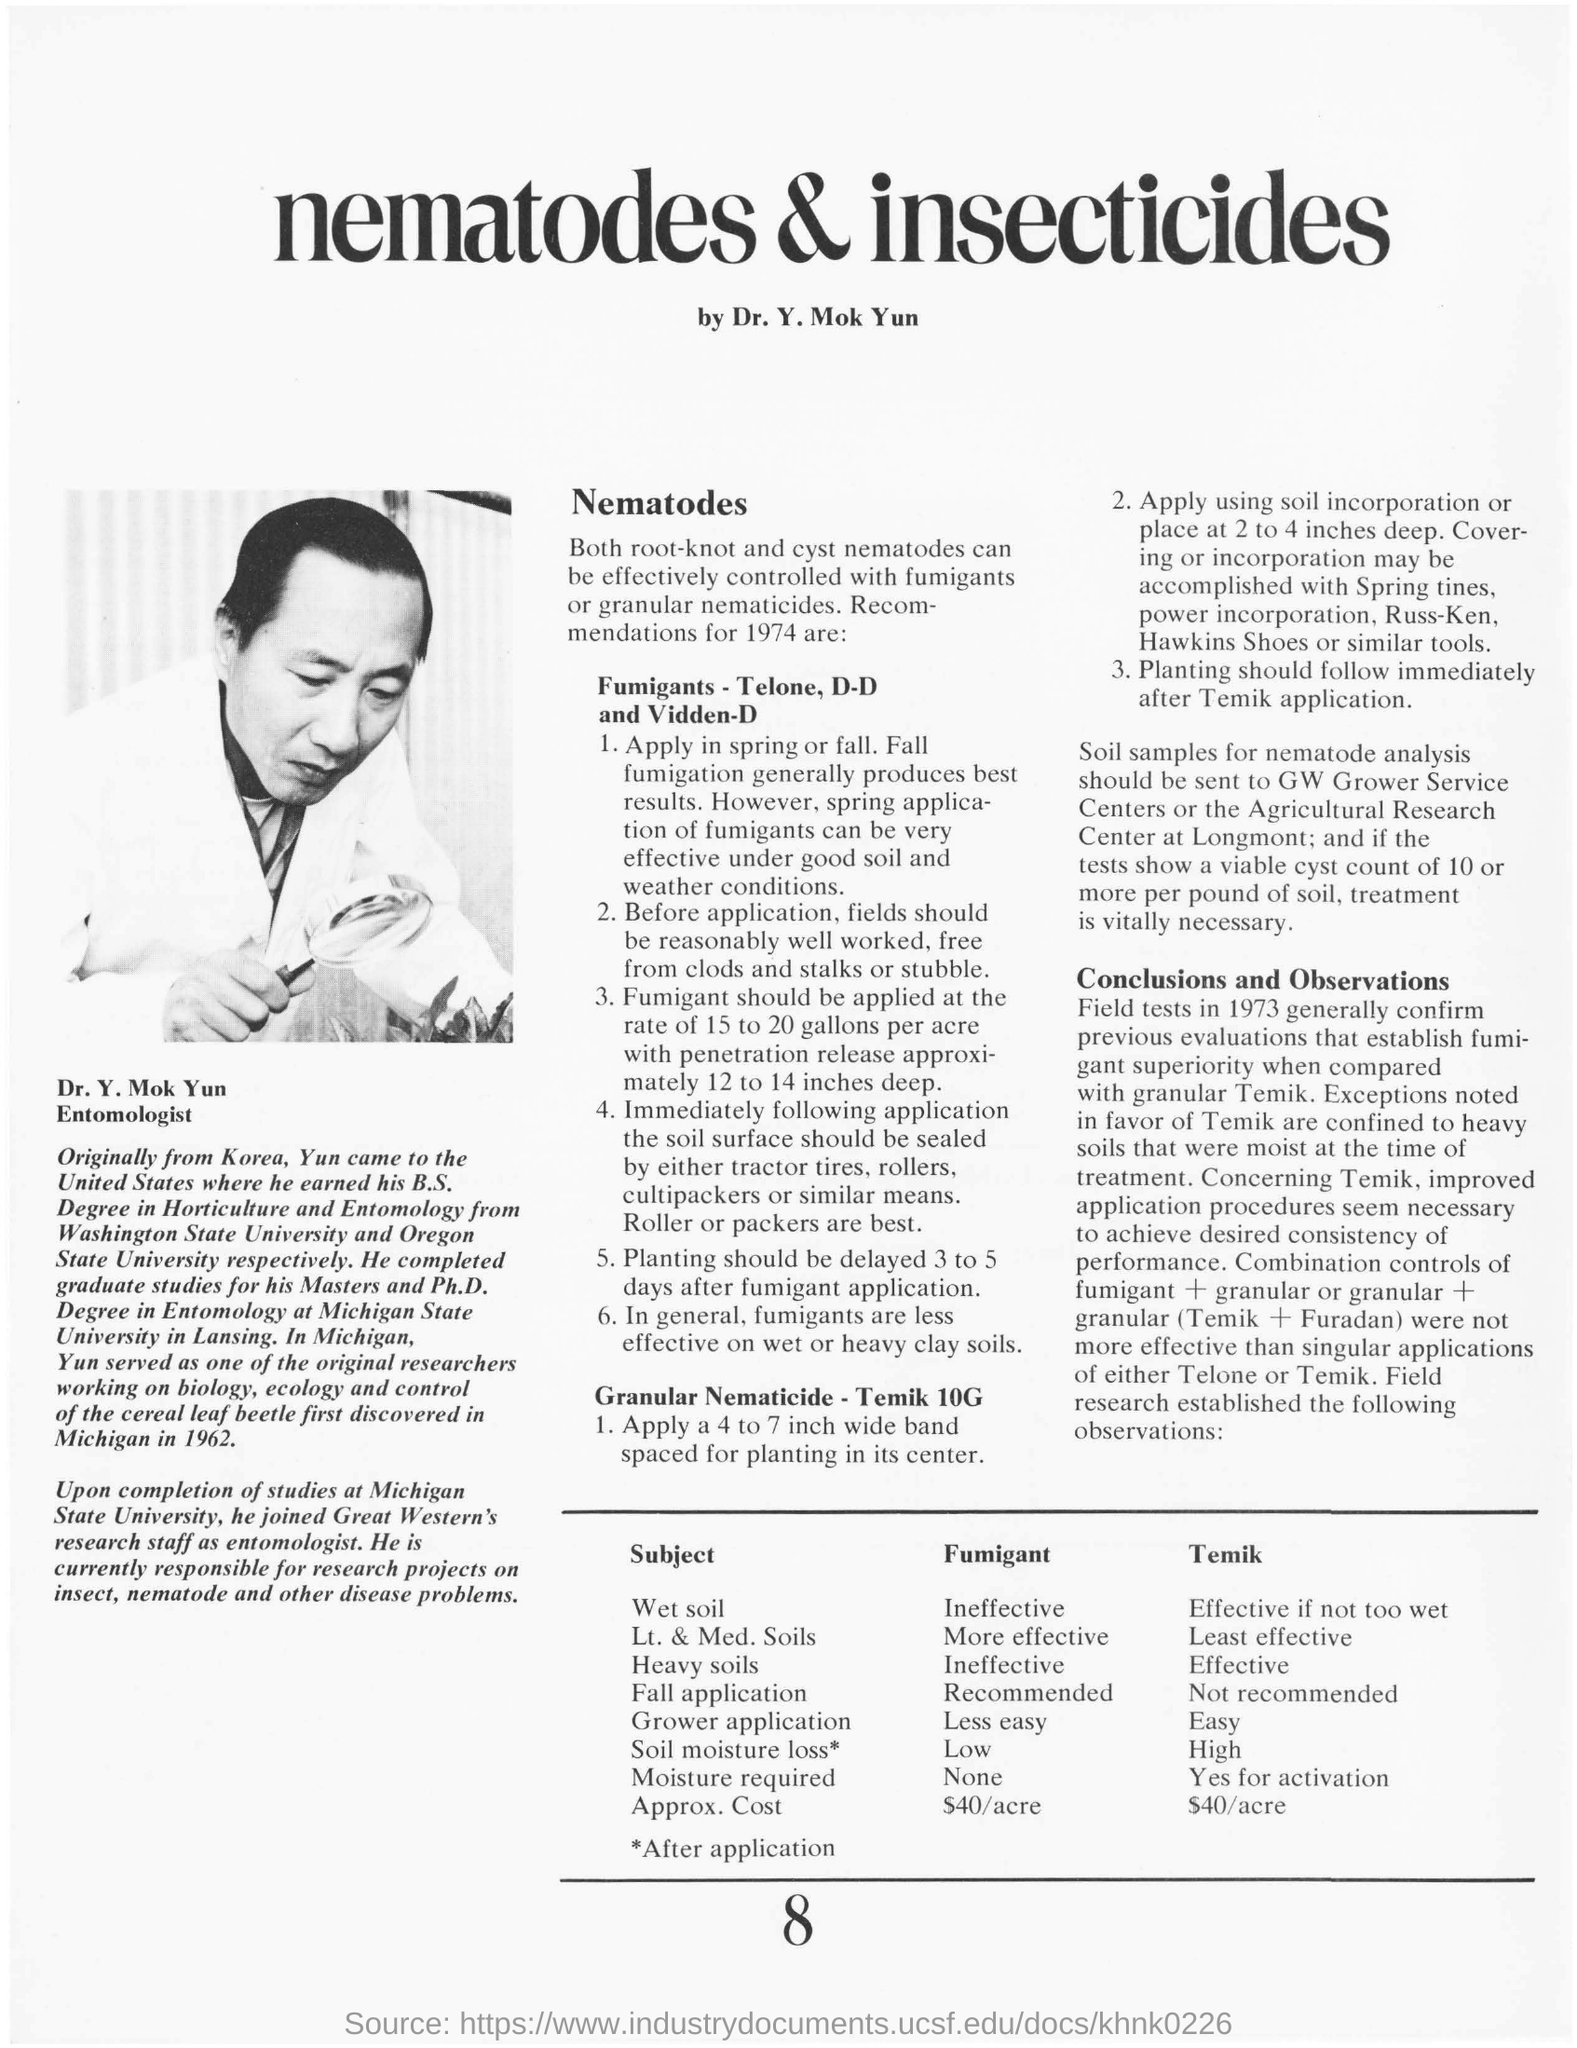Who is doing research projects on insect, nematode and other disease problems?
Ensure brevity in your answer.  Dr. Y. Mok Yun. Under what conditions the spring application of fumigants are very effective?
Provide a succinct answer. Under good soil and weather conditions. What is the rate of fumigant application?
Give a very brief answer. 15 to 20 gallons. How much is the penetration release for fumigant application?
Provide a short and direct response. 12 to 14 inches deep. In which soil condition are fumigants less effective?
Give a very brief answer. On wet or heavy clay soils. Where is the soil samples sent for nematode analysis?
Provide a short and direct response. GW Grower Service Centers or the Agricultural Research Centre at Longmont;. 